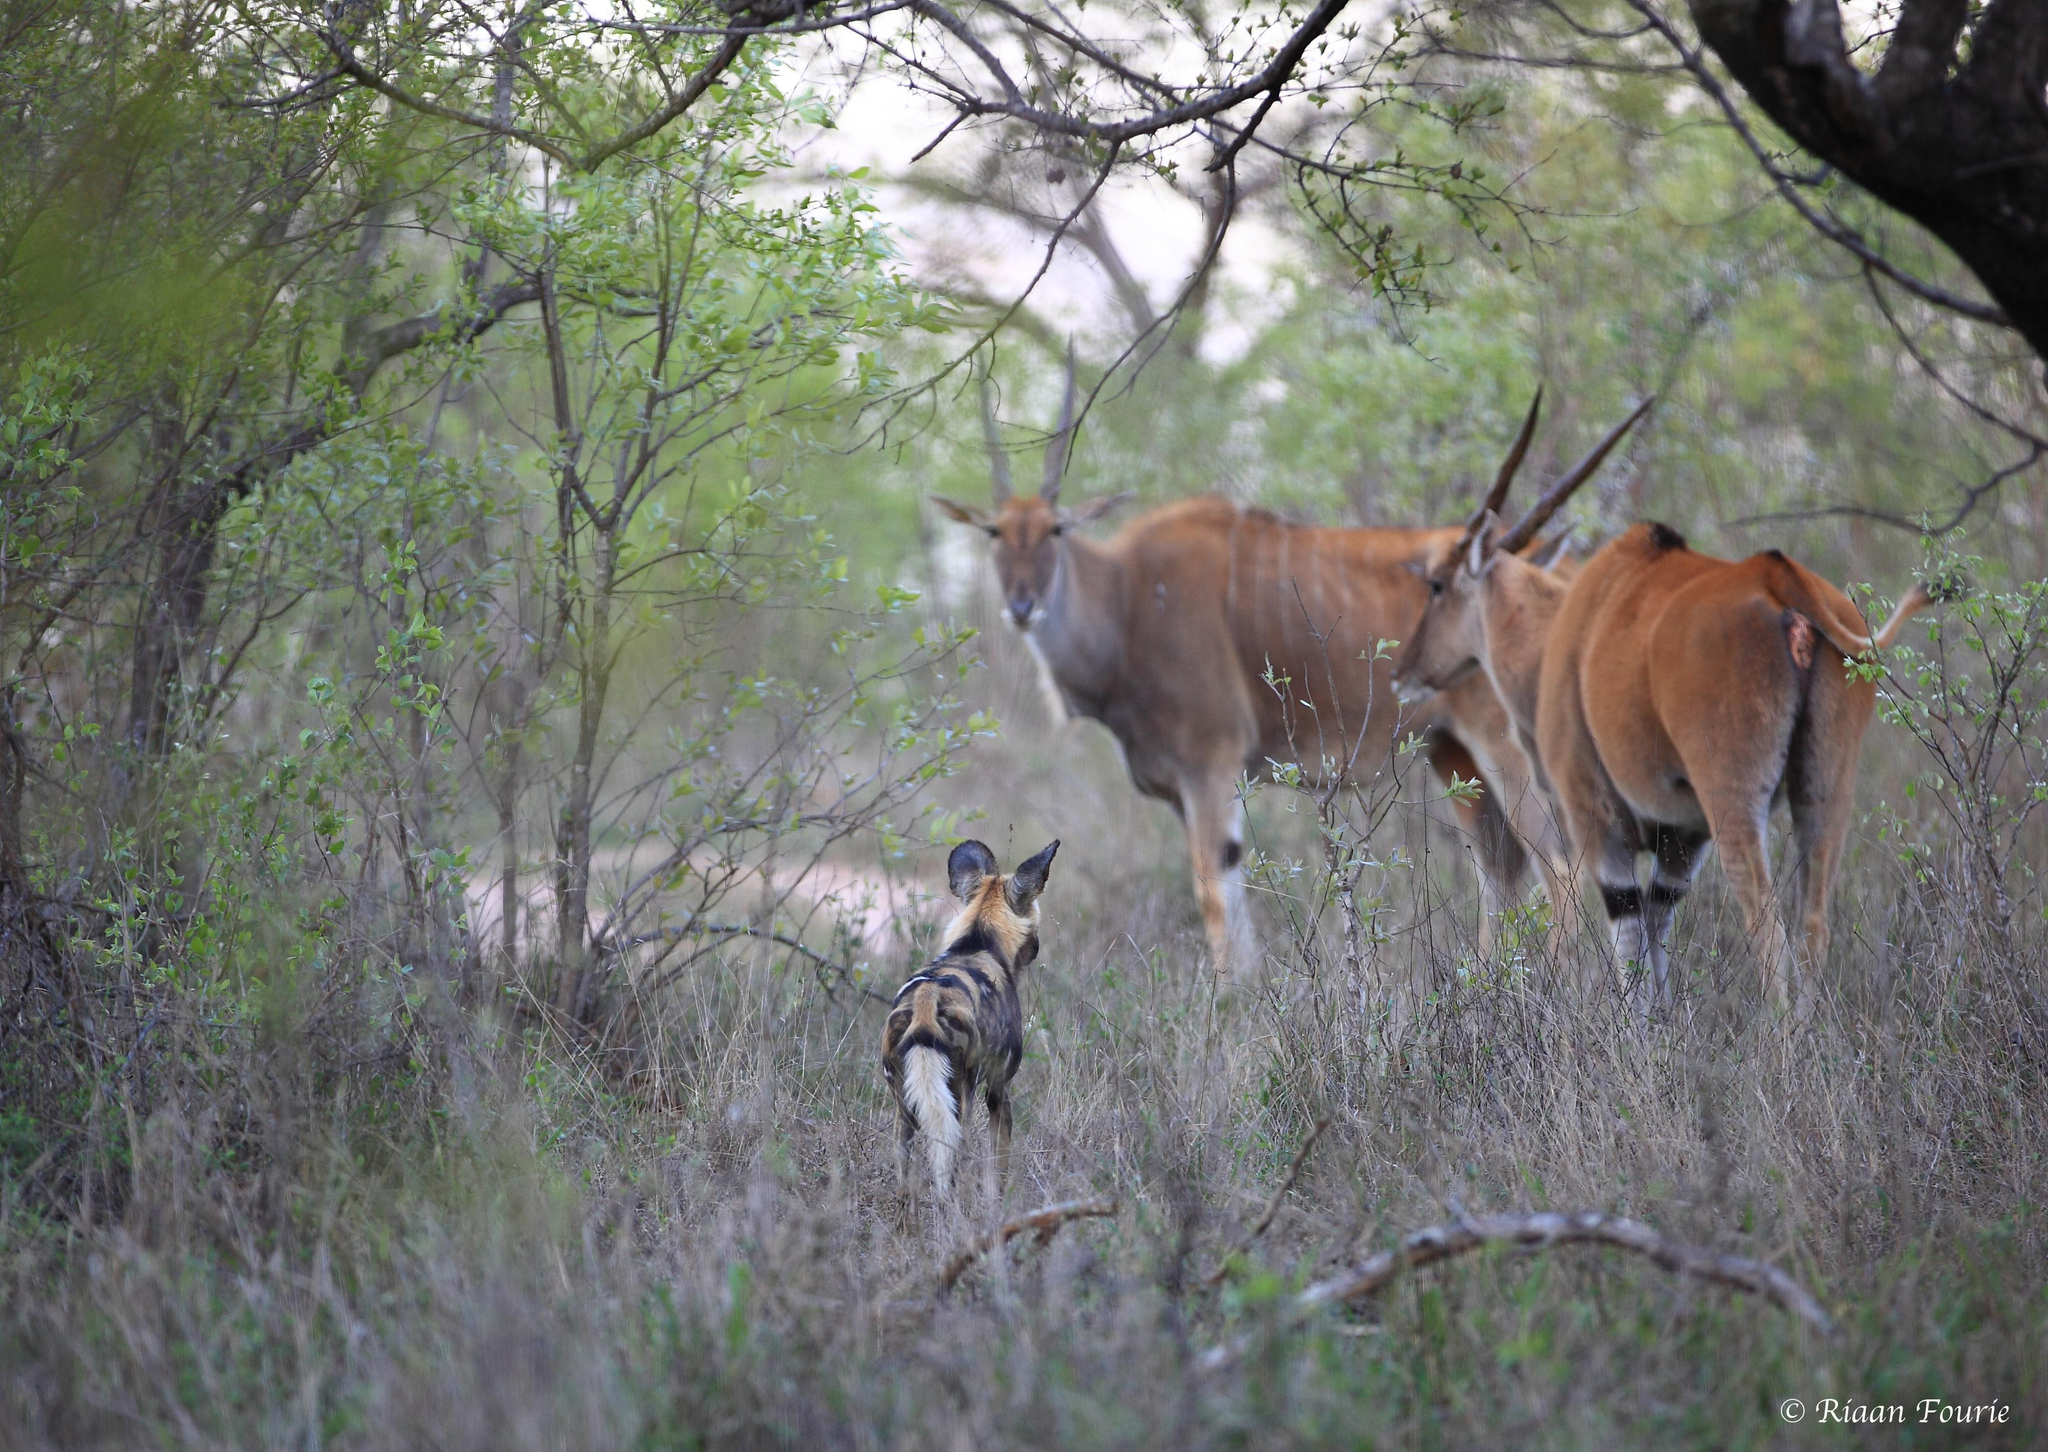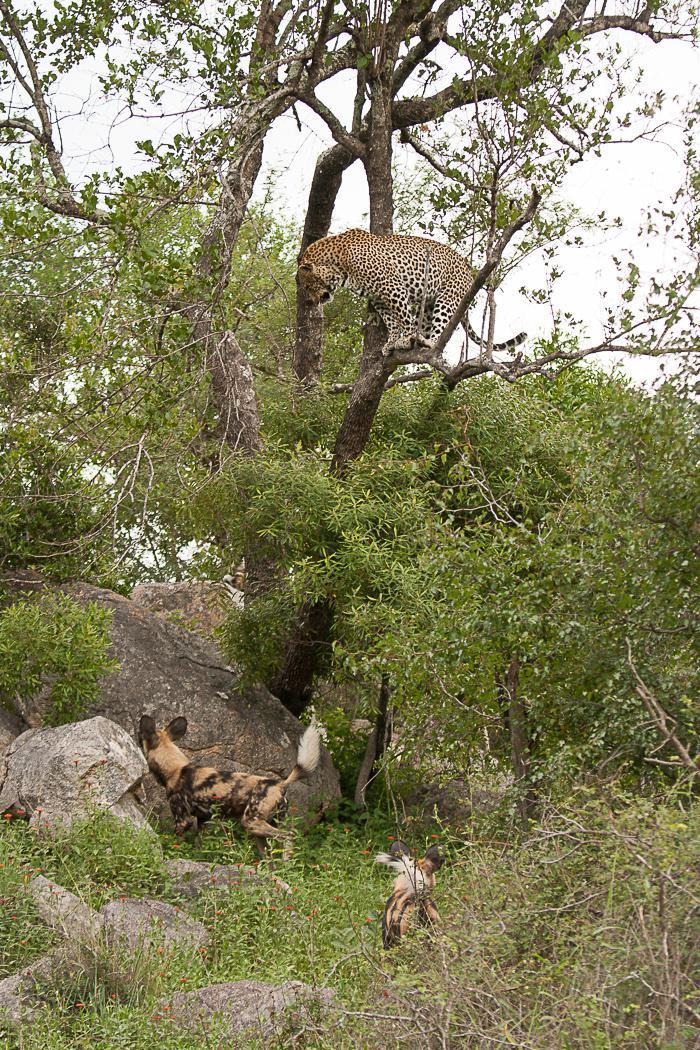The first image is the image on the left, the second image is the image on the right. Evaluate the accuracy of this statement regarding the images: "In one image in the pair, the only animal that can be seen is the hyena.". Is it true? Answer yes or no. No. The first image is the image on the left, the second image is the image on the right. Analyze the images presented: Is the assertion "The left image shows at least one rear-facing hyena standing in front of two larger standing animals with horns." valid? Answer yes or no. Yes. 